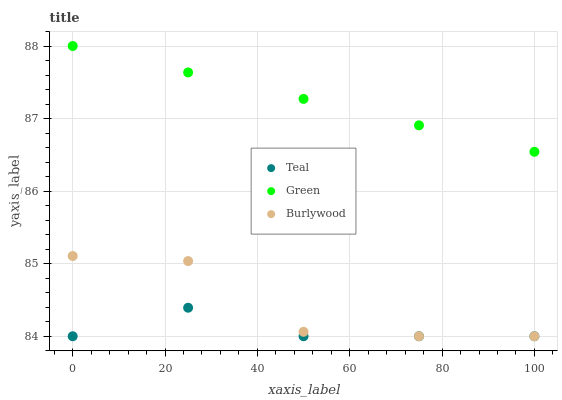Does Teal have the minimum area under the curve?
Answer yes or no. Yes. Does Green have the maximum area under the curve?
Answer yes or no. Yes. Does Green have the minimum area under the curve?
Answer yes or no. No. Does Teal have the maximum area under the curve?
Answer yes or no. No. Is Green the smoothest?
Answer yes or no. Yes. Is Burlywood the roughest?
Answer yes or no. Yes. Is Teal the smoothest?
Answer yes or no. No. Is Teal the roughest?
Answer yes or no. No. Does Burlywood have the lowest value?
Answer yes or no. Yes. Does Green have the lowest value?
Answer yes or no. No. Does Green have the highest value?
Answer yes or no. Yes. Does Teal have the highest value?
Answer yes or no. No. Is Teal less than Green?
Answer yes or no. Yes. Is Green greater than Teal?
Answer yes or no. Yes. Does Teal intersect Burlywood?
Answer yes or no. Yes. Is Teal less than Burlywood?
Answer yes or no. No. Is Teal greater than Burlywood?
Answer yes or no. No. Does Teal intersect Green?
Answer yes or no. No. 